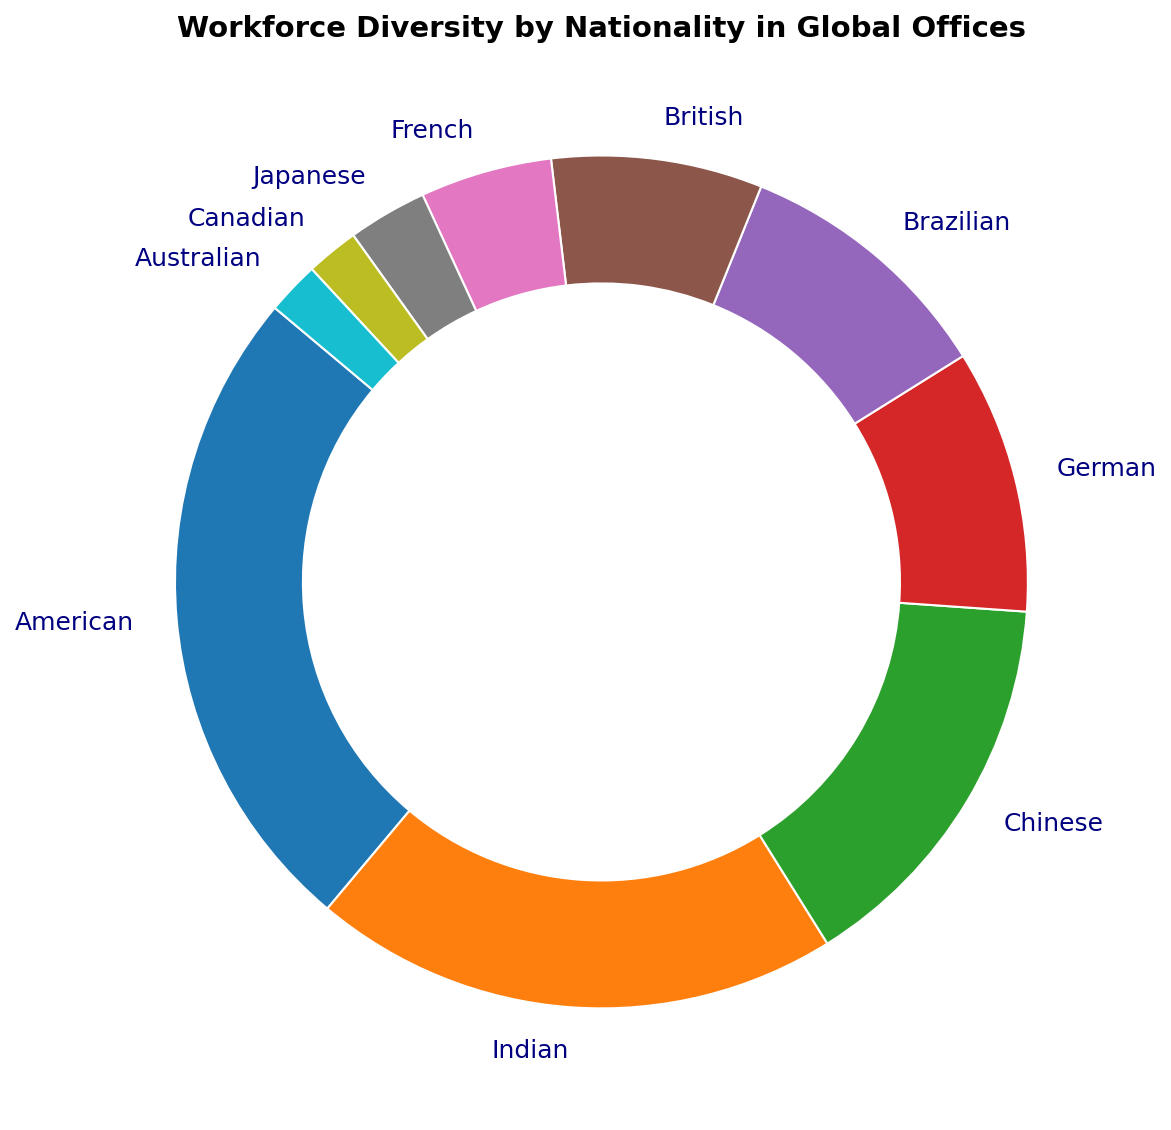What nationality represents the largest portion of the workforce? The American slice is the largest in the ring chart, labeled as 25%. Therefore, Americans represent the largest portion of the workforce.
Answer: American Which two nationalities combined make up a third of the workforce? The percentages of German and Brazilian employees are both 10%. Adding them together results in 20%, which is about one-fifth of the total. Hence, considering Indian (20%) and Chinese (15%), their combined total is 35%, which is more than a third of the workforce. But French (5%) and Brazilian (10%) combined with Americans (25%) add up to 40%. Both groups add up to more than a third. However, herein lies the crucial two nationalities: Indian and Chinese combined at 35%.
Answer: Indian and Chinese Is the proportion of British employees greater than or less than the proportion of Brazilian employees? The proportion of British employees is 8%, while the proportion of Brazilian employees is 10%. Therefore, there are fewer British employees compared to Brazilian employees.
Answer: Less than Which nationalities combined form the smallest percentage of the workforce? The smallest slices in the ring chart are Japanese (3%), Canadian (2%), and Australian (2%). Adding them together gives 7%. This combination is the smallest compared to other single nationalities or combinations.
Answer: Japanese, Canadian, and Australian What is the combined percentage of American, Indian, and Chinese employees in the workforce? The percents for American, Indian, and Chinese employees are 25%, 20%, and 15%, respectively. Adding them together results in 25 + 20 + 15 = 60%.
Answer: 60% Which nationality has a percentage close to the midpoint between the highest and the lowest percentages? The highest percentage (25%, American) and the lowest (2%, each for Canadian and Australian), have a midpoint at (25 + 2) / 2 = 13.5%. The closest percentage to this midpoint is Chinese at 15%.
Answer: Chinese How many nationalities have a representation of 10% or more? The slices for American (25%), Indian (20%), Chinese (15%), and both German and Brazilian (10%) are all equal or greater than 10%. This leads to four nationalities.
Answer: Five Is there an equal distribution between any two nationalities? If so, which ones? By observing the ring chart, the German and Brazilian slices are visibly equal, each occupying 10% of the workforce.
Answer: German and Brazilian Compare the combined percentages of European nationalities (German, British, French) and Asian nationalities (Indian, Chinese, Japanese). Which group occupies a larger percentage of the workforce? European nationalities: German (10%) + British (8%) + French (5%) = 23%. Asian nationalities: Indian (20%) + Chinese (15%) + Japanese (3%) = 38%. Hence, the Asian nationalities have a larger combined percentage.
Answer: Asian nationalities How much larger is the percentage of American employees compared to Japanese employees? The percentage of American employees is 25%, Japanese is 3%. The difference is 25 - 3 = 22%.
Answer: 22% 